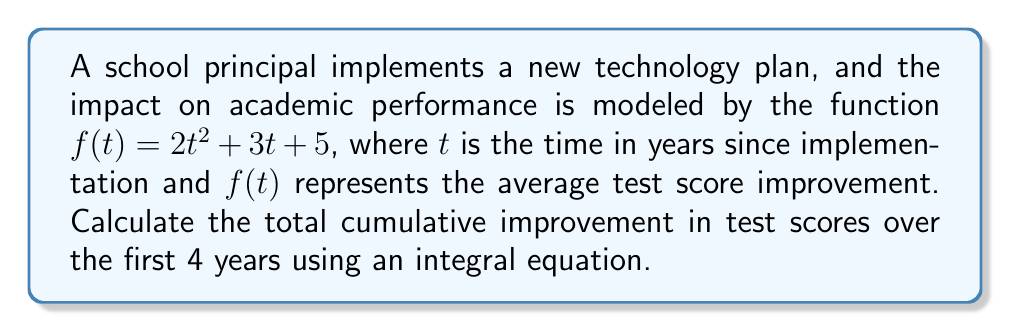Provide a solution to this math problem. To solve this problem, we need to follow these steps:

1) The cumulative improvement over time is represented by the area under the curve of $f(t)$ from $t=0$ to $t=4$.

2) This can be calculated using a definite integral:

   $$\int_0^4 f(t) dt$$

3) Substituting our function:

   $$\int_0^4 (2t^2 + 3t + 5) dt$$

4) Integrate each term:
   
   $$\left[\frac{2t^3}{3} + \frac{3t^2}{2} + 5t\right]_0^4$$

5) Evaluate at the upper and lower bounds:

   $$\left(\frac{2(4^3)}{3} + \frac{3(4^2)}{2} + 5(4)\right) - \left(\frac{2(0^3)}{3} + \frac{3(0^2)}{2} + 5(0)\right)$$

6) Simplify:

   $$\left(\frac{128}{3} + 24 + 20\right) - (0)$$

7) Calculate:

   $$\frac{128}{3} + 44 = \frac{128 + 132}{3} = \frac{260}{3} \approx 86.67$$
Answer: $\frac{260}{3}$ or approximately 86.67 